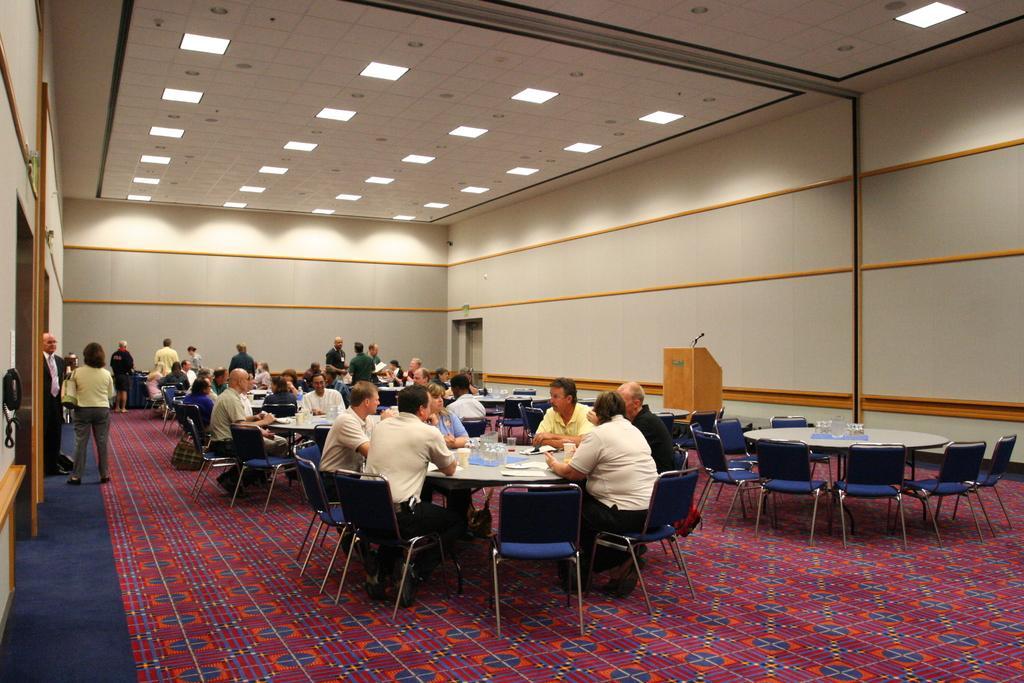Can you describe this image briefly? In this picture there is a group of men and women sitting in the big hall for the meeting. In the front bottom side there is a red color carpet. On the top ceiling there are some spotlights. 